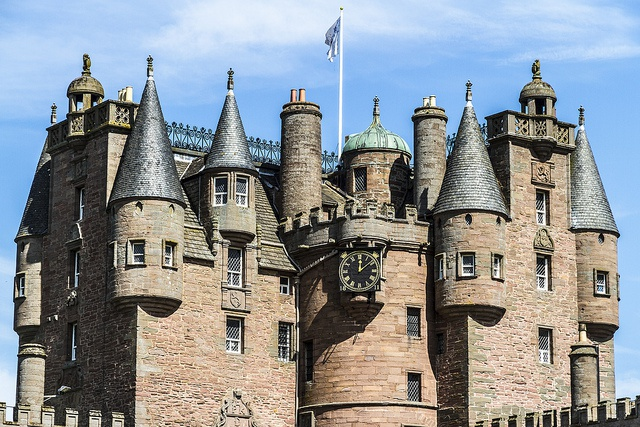Describe the objects in this image and their specific colors. I can see a clock in lightblue, black, gray, and darkgray tones in this image. 